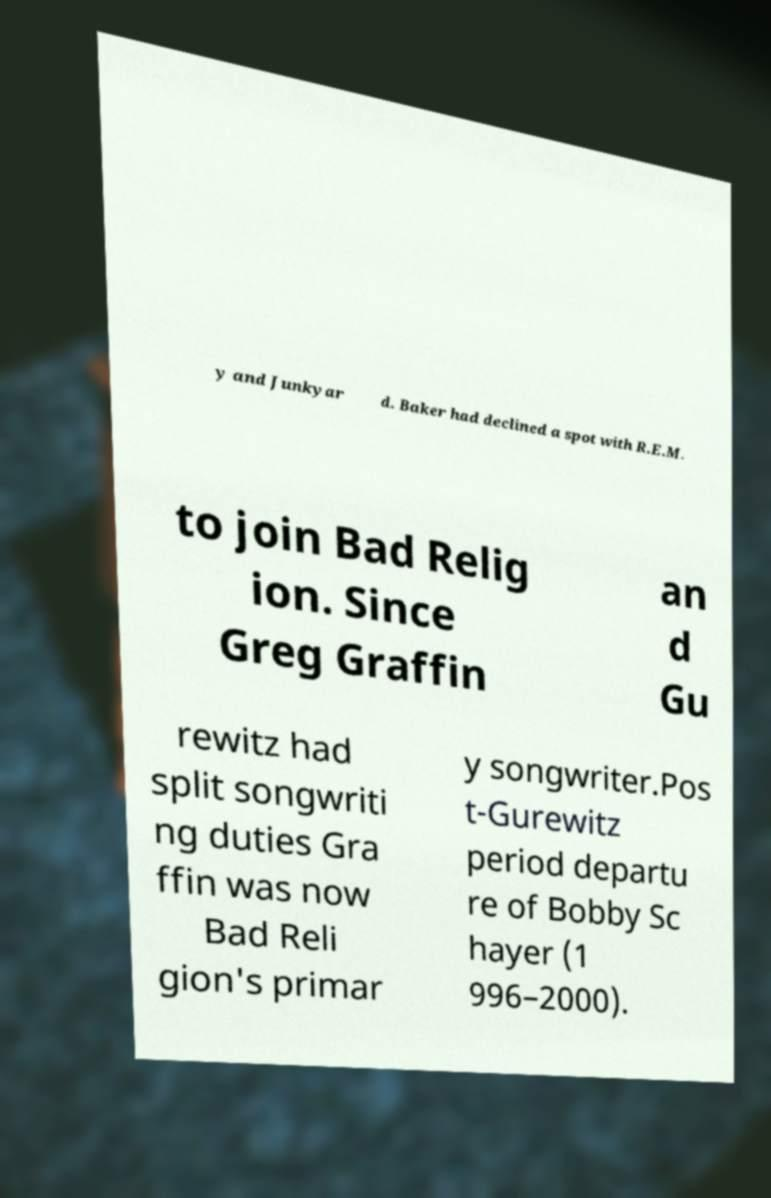Please identify and transcribe the text found in this image. y and Junkyar d. Baker had declined a spot with R.E.M. to join Bad Relig ion. Since Greg Graffin an d Gu rewitz had split songwriti ng duties Gra ffin was now Bad Reli gion's primar y songwriter.Pos t-Gurewitz period departu re of Bobby Sc hayer (1 996–2000). 